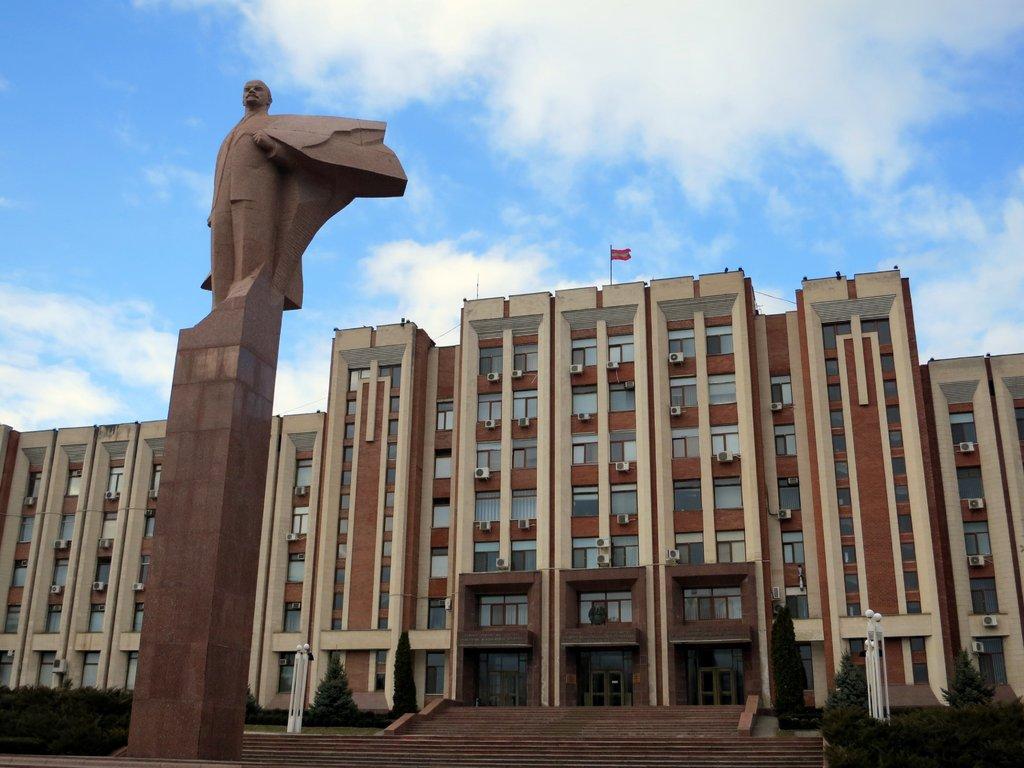Please provide a concise description of this image. In this image I can see the person statue and I can see few light poles, trees. In the background I can see the flag, building in brown and cream color and the sky is in blue and white color. 